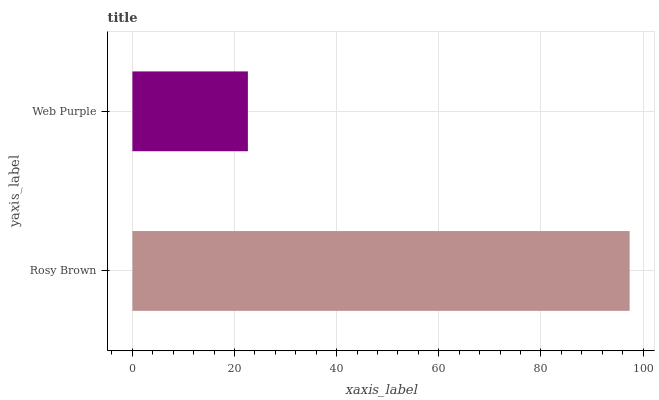Is Web Purple the minimum?
Answer yes or no. Yes. Is Rosy Brown the maximum?
Answer yes or no. Yes. Is Web Purple the maximum?
Answer yes or no. No. Is Rosy Brown greater than Web Purple?
Answer yes or no. Yes. Is Web Purple less than Rosy Brown?
Answer yes or no. Yes. Is Web Purple greater than Rosy Brown?
Answer yes or no. No. Is Rosy Brown less than Web Purple?
Answer yes or no. No. Is Rosy Brown the high median?
Answer yes or no. Yes. Is Web Purple the low median?
Answer yes or no. Yes. Is Web Purple the high median?
Answer yes or no. No. Is Rosy Brown the low median?
Answer yes or no. No. 